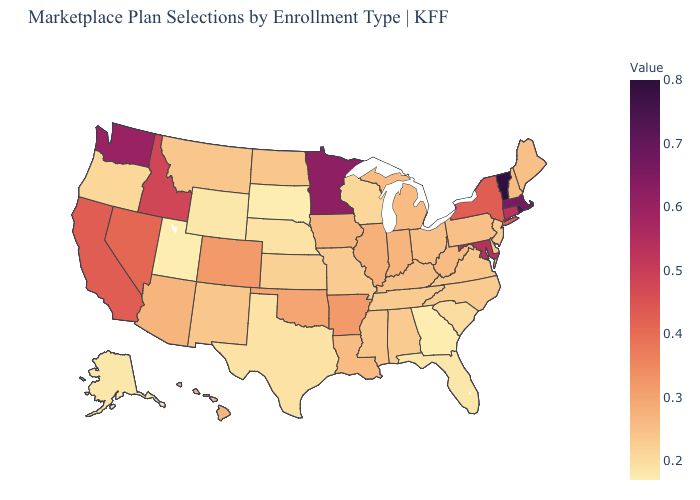Which states hav the highest value in the West?
Be succinct. Washington. Which states have the highest value in the USA?
Write a very short answer. Vermont. Which states have the highest value in the USA?
Concise answer only. Vermont. Which states have the lowest value in the USA?
Concise answer only. Georgia, South Dakota, Utah. Which states have the lowest value in the USA?
Concise answer only. Georgia, South Dakota, Utah. Among the states that border Iowa , which have the highest value?
Concise answer only. Minnesota. 